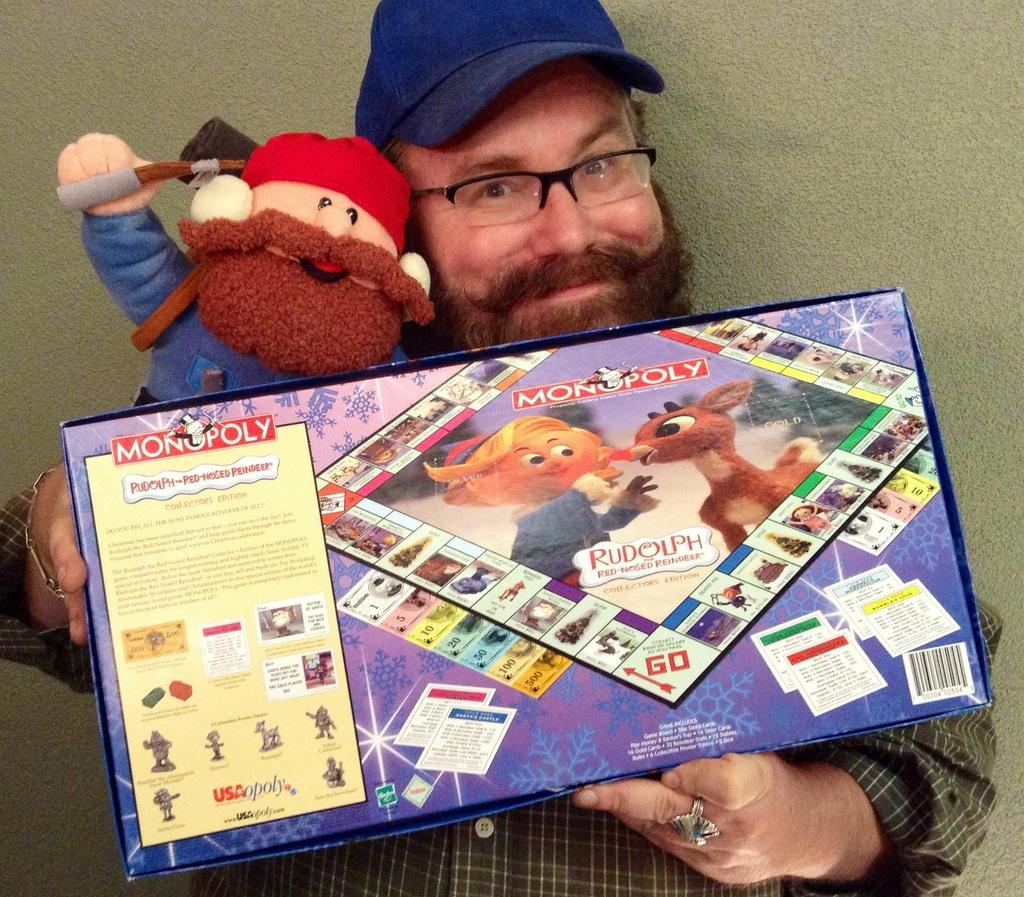What can be seen in the image? There is a person in the image. Can you describe the person's appearance? The person is wearing specs and a cap. What is the person holding in the image? The person is holding a toy and a box. What is written on the box? There is writing on the box. Are there any images on the box? Yes, there are images on the box. What is visible in the background of the image? There is a wall in the background of the image. Can you tell me how many boats are docked at the harbor in the image? There is no harbor or boats present in the image; it features a person holding a toy and a box. What type of lettuce is being used as a prop in the image? There is no lettuce present in the image. 